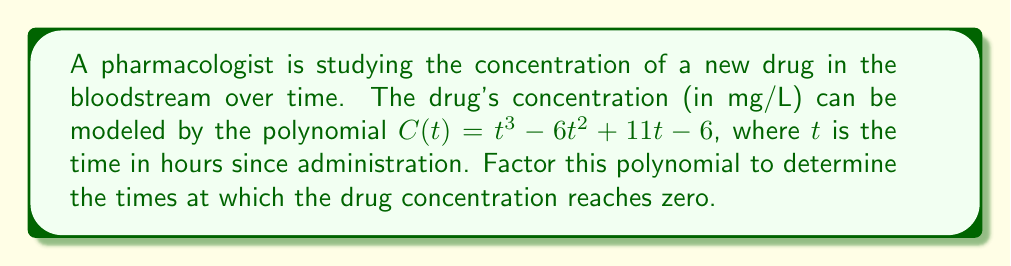Teach me how to tackle this problem. To factor this polynomial, we'll follow these steps:

1) First, let's check if there's a common factor. There isn't, so we proceed.

2) This is a cubic polynomial. Let's try to find a root by guessing. Since the constant term is -6, possible factors could be ±1, ±2, ±3, ±6. Let's try t = 1:

   $C(1) = 1^3 - 6(1)^2 + 11(1) - 6 = 1 - 6 + 11 - 6 = 0$

   So, (t - 1) is a factor.

3) We can now use polynomial long division to divide $t^3 - 6t^2 + 11t - 6$ by $(t - 1)$:

   $$\frac{t^3 - 6t^2 + 11t - 6}{t - 1} = t^2 - 5t + 6$$

4) So now we have: $C(t) = (t - 1)(t^2 - 5t + 6)$

5) The quadratic factor $t^2 - 5t + 6$ can be factored further:
   
   $t^2 - 5t + 6 = (t - 2)(t - 3)$

6) Therefore, the fully factored polynomial is:

   $C(t) = (t - 1)(t - 2)(t - 3)$

The roots of this polynomial (where C(t) = 0) are at t = 1, t = 2, and t = 3.
Answer: $C(t) = (t - 1)(t - 2)(t - 3)$
The drug concentration reaches zero at 1 hour, 2 hours, and 3 hours after administration. 